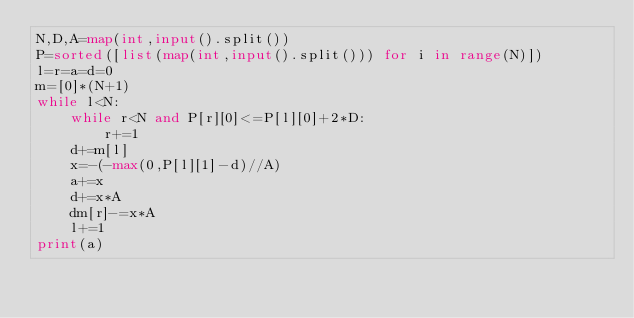<code> <loc_0><loc_0><loc_500><loc_500><_Python_>N,D,A=map(int,input().split())
P=sorted([list(map(int,input().split())) for i in range(N)])
l=r=a=d=0
m=[0]*(N+1)
while l<N:
    while r<N and P[r][0]<=P[l][0]+2*D:
        r+=1
    d+=m[l]
    x=-(-max(0,P[l][1]-d)//A)
    a+=x
    d+=x*A
    dm[r]-=x*A
    l+=1
print(a)
</code> 